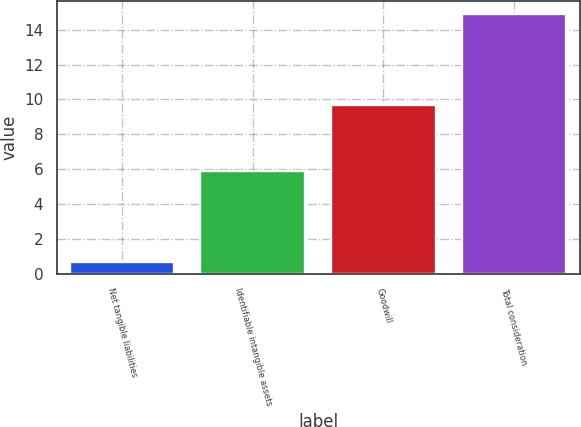<chart> <loc_0><loc_0><loc_500><loc_500><bar_chart><fcel>Net tangible liabilities<fcel>Identifiable intangible assets<fcel>Goodwill<fcel>Total consideration<nl><fcel>0.7<fcel>5.9<fcel>9.7<fcel>14.9<nl></chart> 